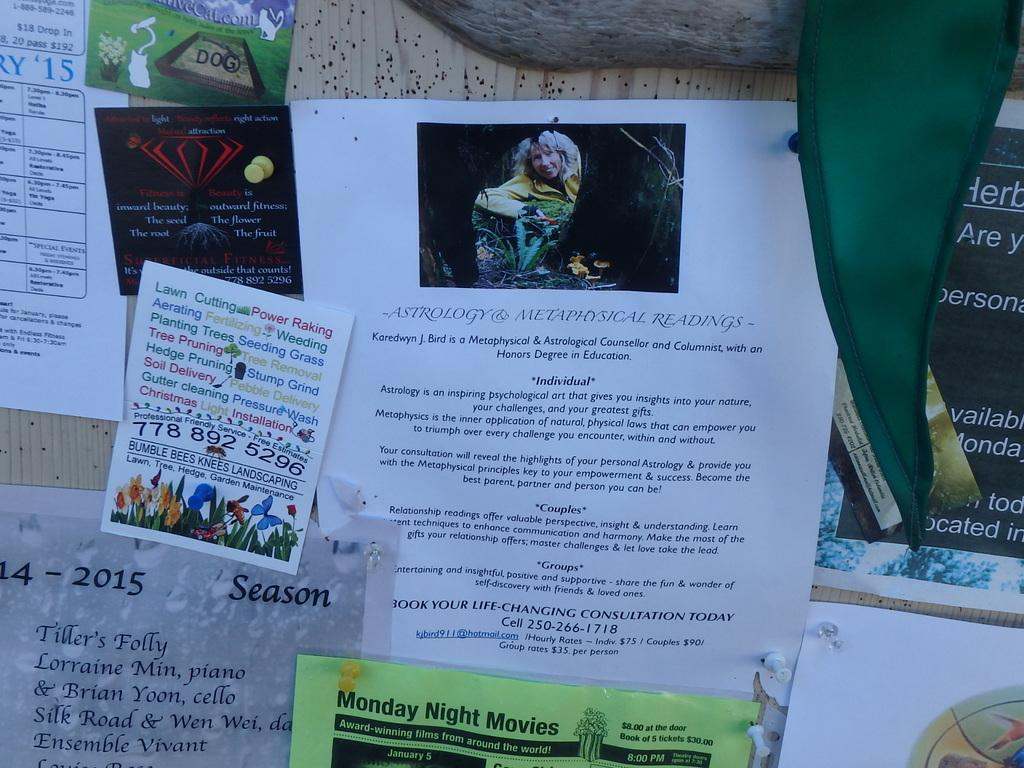<image>
Relay a brief, clear account of the picture shown. A bulletin board has several advertisements including astrology and metaphysical reading services. 